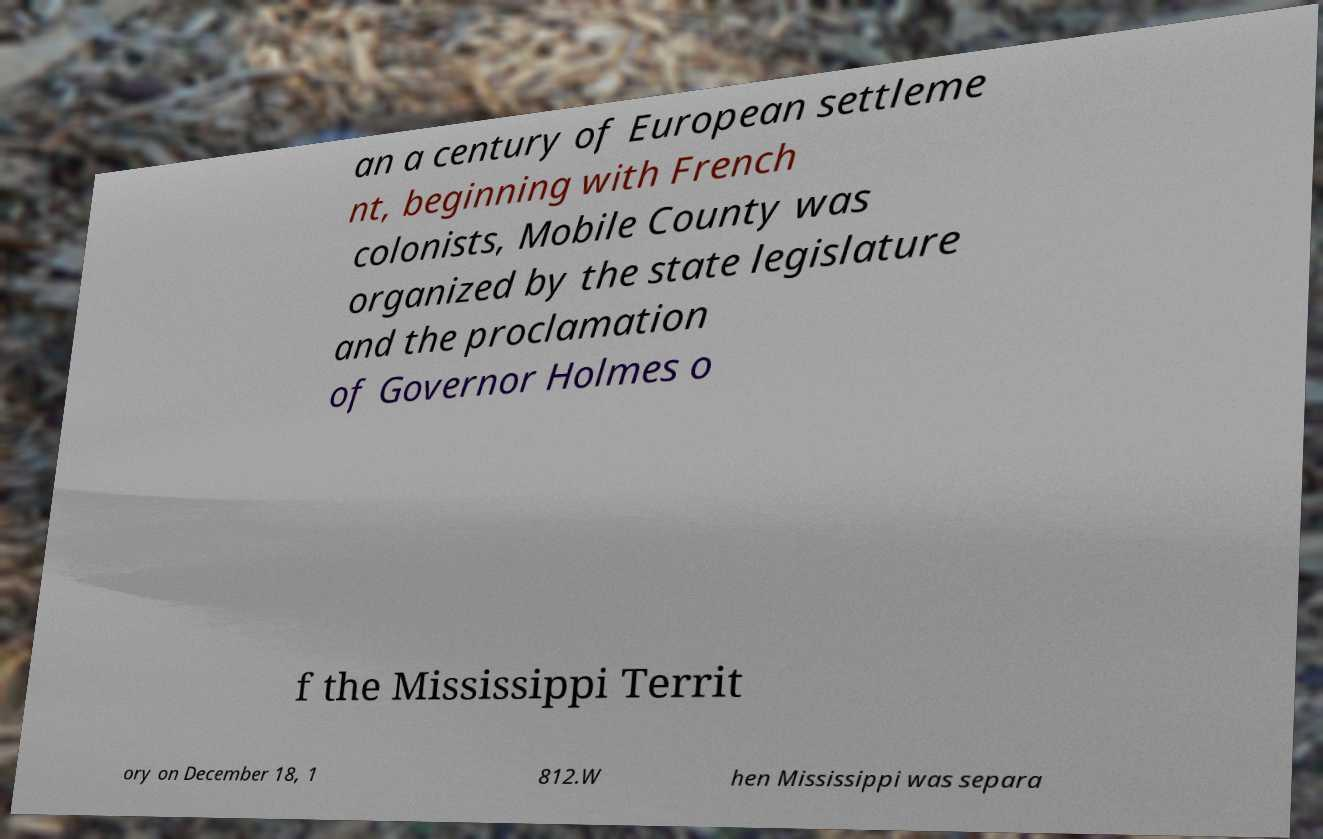Could you extract and type out the text from this image? an a century of European settleme nt, beginning with French colonists, Mobile County was organized by the state legislature and the proclamation of Governor Holmes o f the Mississippi Territ ory on December 18, 1 812.W hen Mississippi was separa 